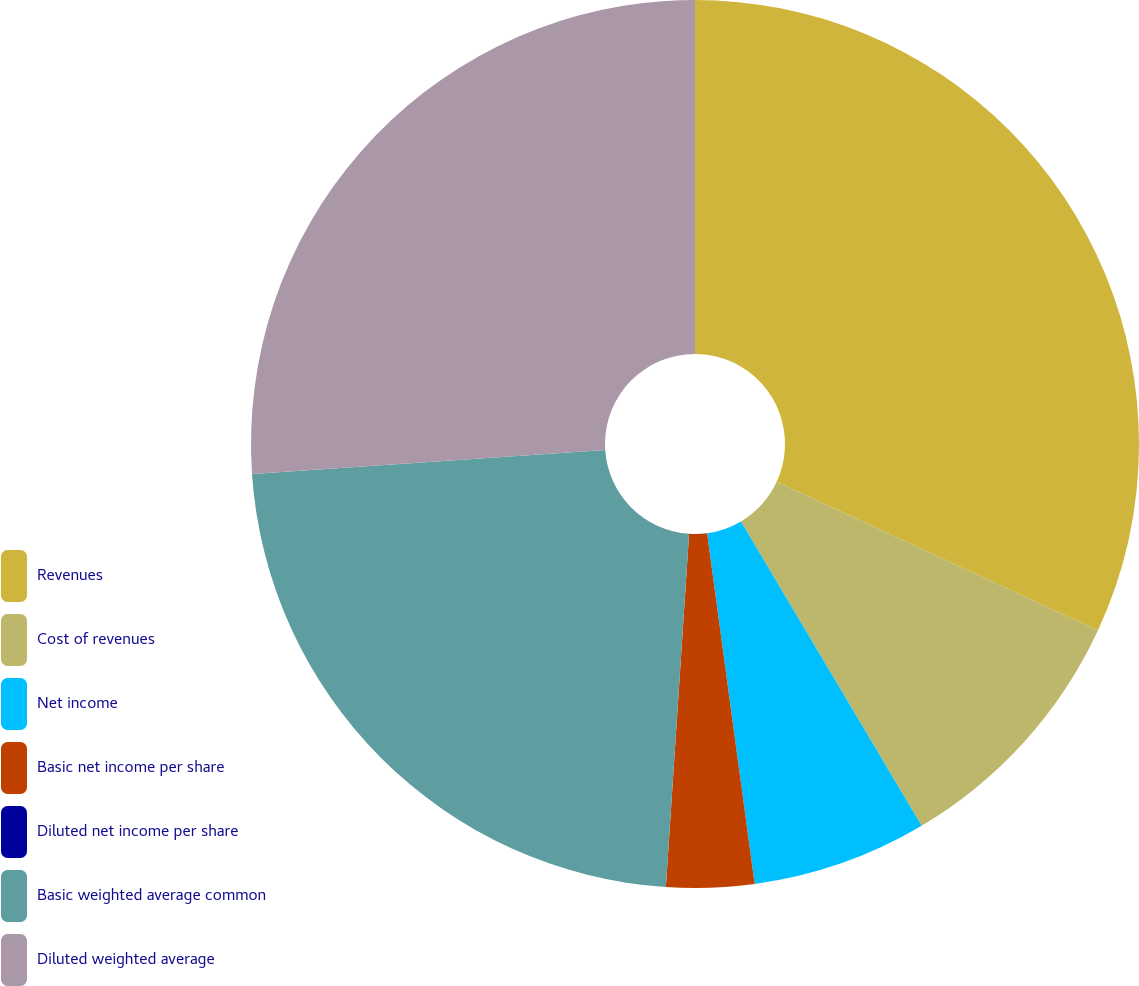Convert chart. <chart><loc_0><loc_0><loc_500><loc_500><pie_chart><fcel>Revenues<fcel>Cost of revenues<fcel>Net income<fcel>Basic net income per share<fcel>Diluted net income per share<fcel>Basic weighted average common<fcel>Diluted weighted average<nl><fcel>31.9%<fcel>9.57%<fcel>6.38%<fcel>3.19%<fcel>0.0%<fcel>22.88%<fcel>26.07%<nl></chart> 